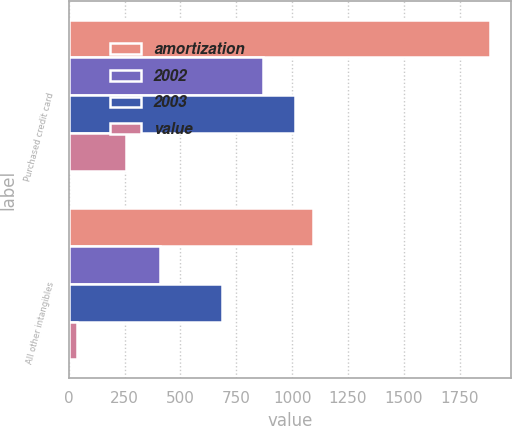<chart> <loc_0><loc_0><loc_500><loc_500><stacked_bar_chart><ecel><fcel>Purchased credit card<fcel>All other intangibles<nl><fcel>amortization<fcel>1885<fcel>1093<nl><fcel>2002<fcel>871<fcel>408<nl><fcel>2003<fcel>1014<fcel>685<nl><fcel>value<fcel>256<fcel>38<nl></chart> 